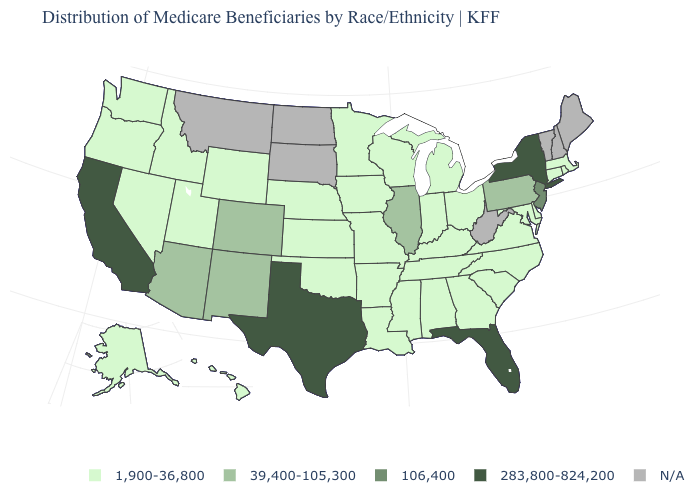What is the value of Pennsylvania?
Keep it brief. 39,400-105,300. What is the value of Arkansas?
Short answer required. 1,900-36,800. Among the states that border Utah , which have the highest value?
Write a very short answer. Arizona, Colorado, New Mexico. Does the first symbol in the legend represent the smallest category?
Quick response, please. Yes. Among the states that border South Carolina , which have the highest value?
Be succinct. Georgia, North Carolina. Among the states that border Arizona , does Nevada have the lowest value?
Short answer required. Yes. Does Pennsylvania have the lowest value in the Northeast?
Give a very brief answer. No. Name the states that have a value in the range 106,400?
Write a very short answer. New Jersey. Which states have the highest value in the USA?
Give a very brief answer. California, Florida, New York, Texas. What is the value of Oregon?
Short answer required. 1,900-36,800. Which states have the lowest value in the Northeast?
Concise answer only. Connecticut, Massachusetts, Rhode Island. What is the lowest value in states that border Montana?
Write a very short answer. 1,900-36,800. What is the highest value in the USA?
Answer briefly. 283,800-824,200. Which states have the lowest value in the Northeast?
Concise answer only. Connecticut, Massachusetts, Rhode Island. What is the value of Montana?
Be succinct. N/A. 